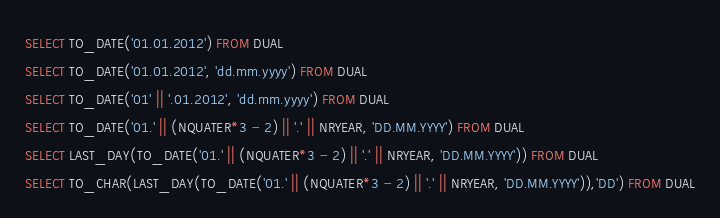Convert code to text. <code><loc_0><loc_0><loc_500><loc_500><_SQL_>SELECT TO_DATE('01.01.2012') FROM DUAL
SELECT TO_DATE('01.01.2012', 'dd.mm.yyyy') FROM DUAL
SELECT TO_DATE('01' || '.01.2012', 'dd.mm.yyyy') FROM DUAL
SELECT TO_DATE('01.' || (NQUATER*3 - 2) || '.' || NRYEAR, 'DD.MM.YYYY') FROM DUAL
SELECT LAST_DAY(TO_DATE('01.' || (NQUATER*3 - 2) || '.' || NRYEAR, 'DD.MM.YYYY')) FROM DUAL
SELECT TO_CHAR(LAST_DAY(TO_DATE('01.' || (NQUATER*3 - 2) || '.' || NRYEAR, 'DD.MM.YYYY')),'DD') FROM DUAL</code> 